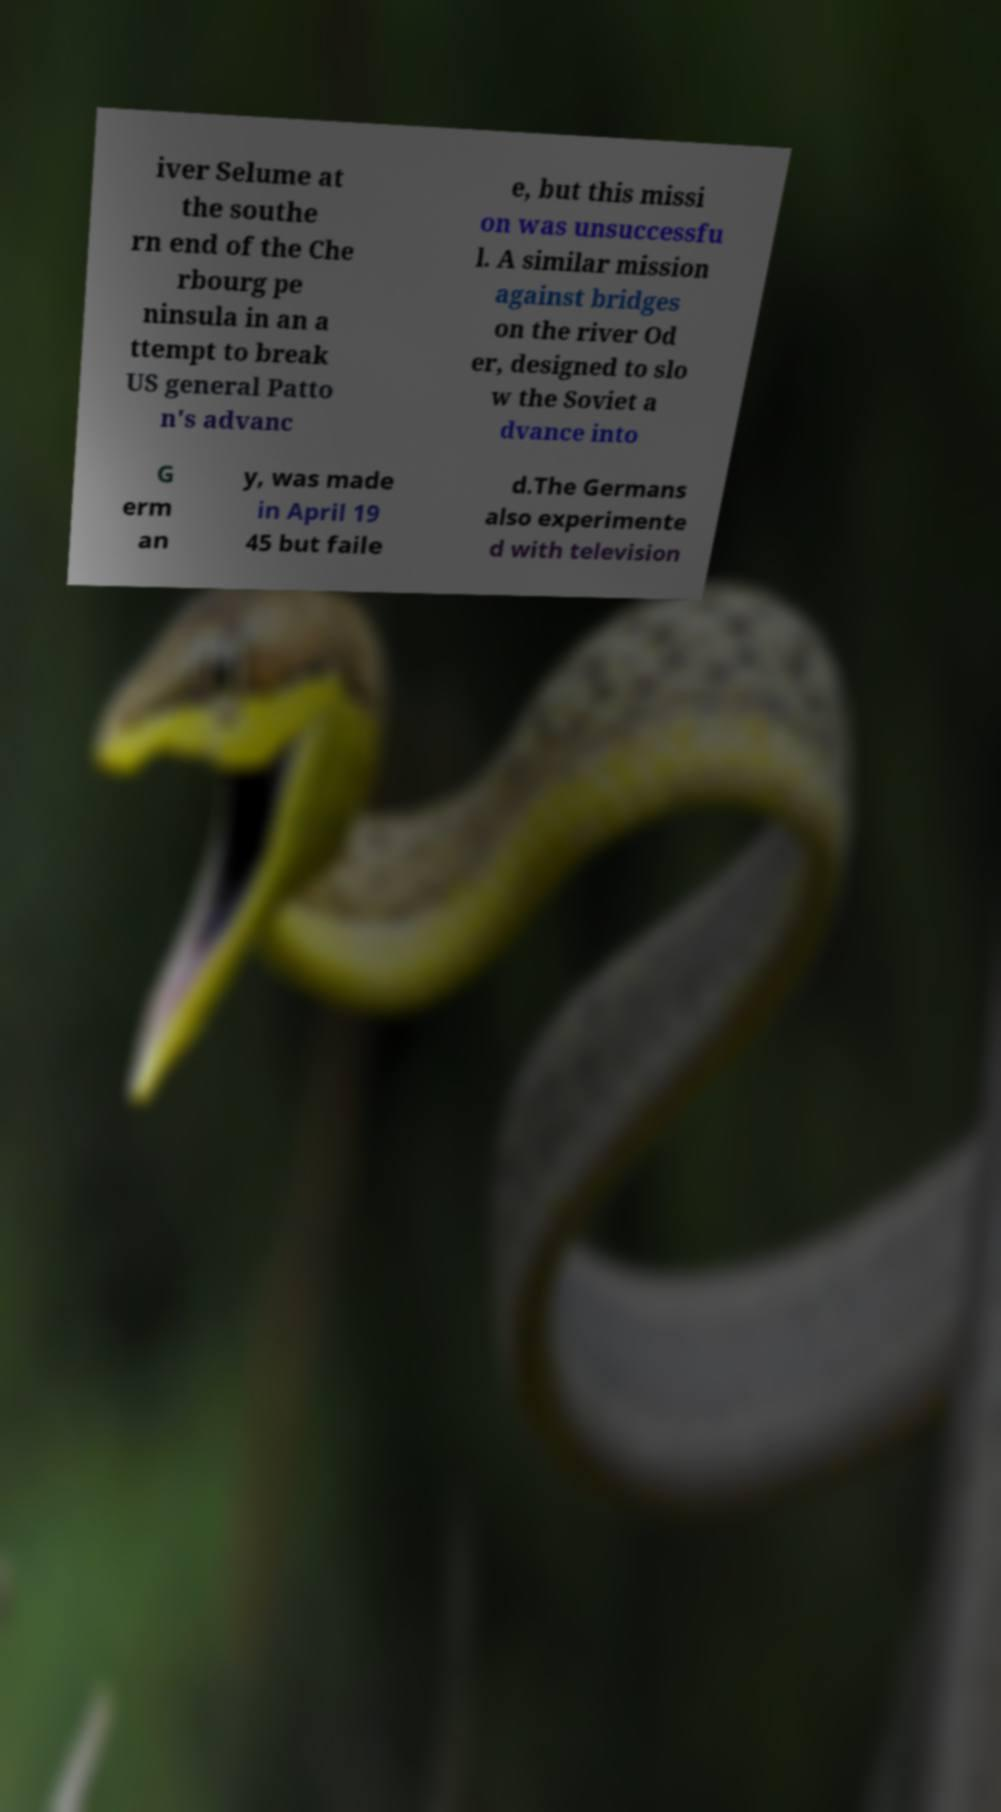Could you assist in decoding the text presented in this image and type it out clearly? iver Selume at the southe rn end of the Che rbourg pe ninsula in an a ttempt to break US general Patto n's advanc e, but this missi on was unsuccessfu l. A similar mission against bridges on the river Od er, designed to slo w the Soviet a dvance into G erm an y, was made in April 19 45 but faile d.The Germans also experimente d with television 